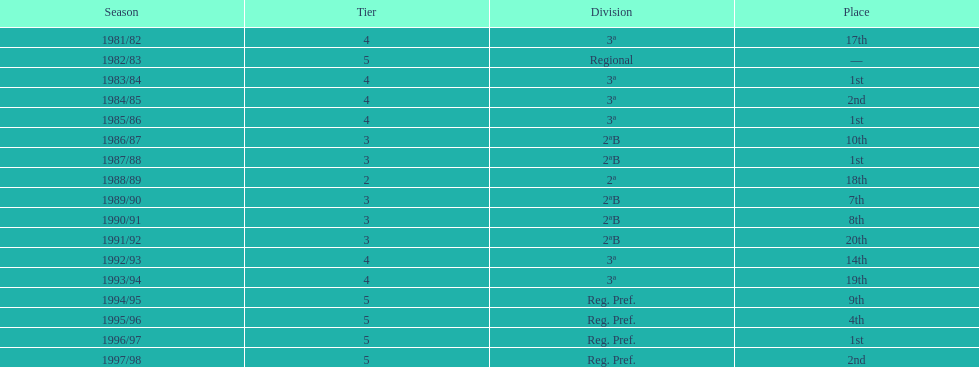During what year was the team last part of division 2? 1991/92. 